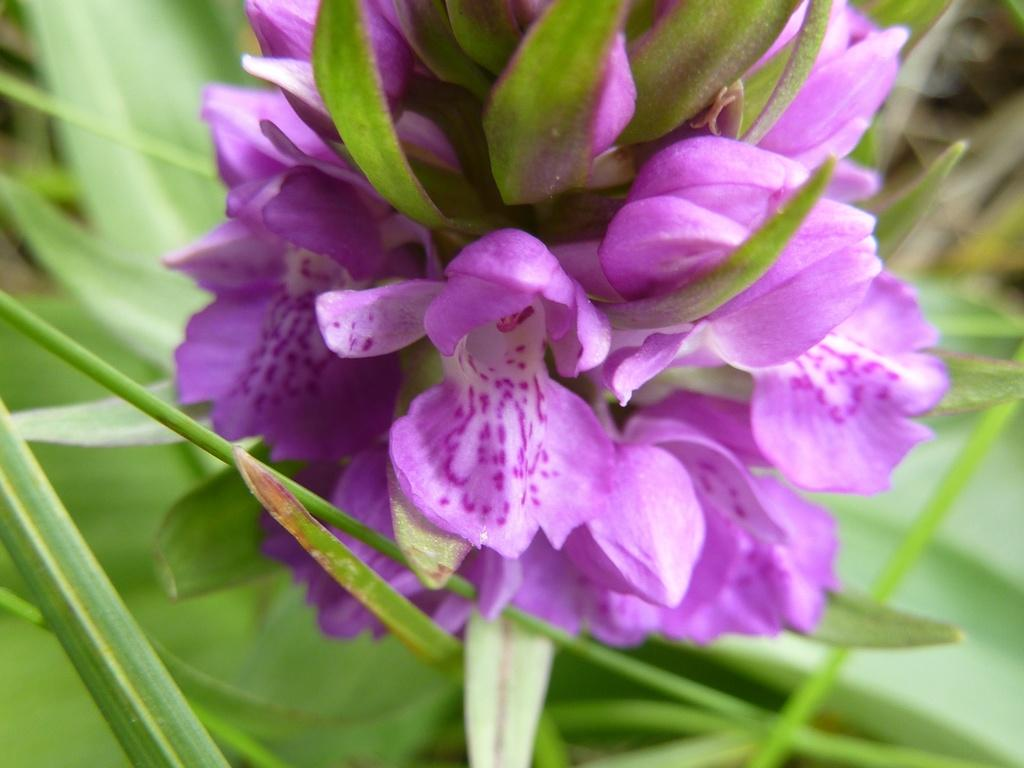What is the main subject in the center of the image? There are flowers in the center of the image. What type of vegetation is visible in the background of the image? There are green leaves in the background of the image. Can you describe any other objects visible in the background of the image? There are other objects visible in the background of the image, but their specific details are not mentioned in the provided facts. How does the mind of the flower in the image work? The image does not depict a mind or any cognitive abilities of the flower, as flowers are not capable of having thoughts or feelings. 